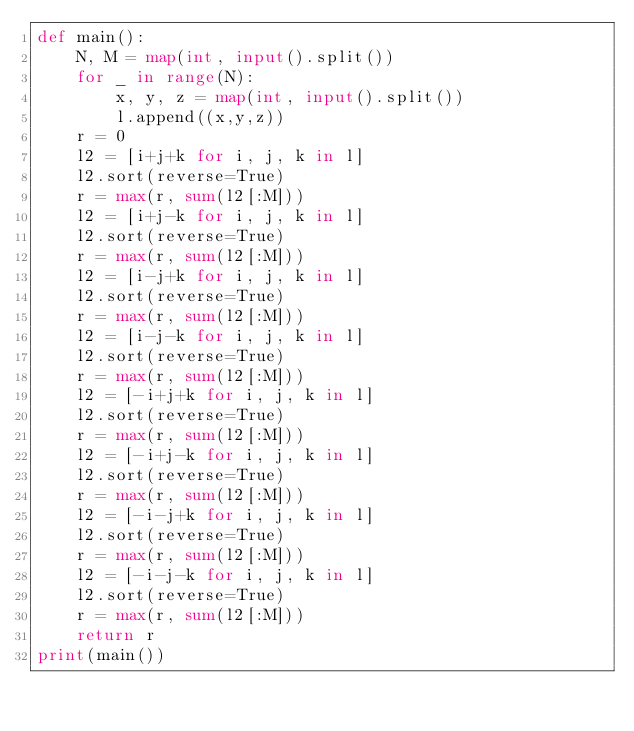<code> <loc_0><loc_0><loc_500><loc_500><_Python_>def main():
    N, M = map(int, input().split())
    for _ in range(N):
        x, y, z = map(int, input().split())
        l.append((x,y,z))
    r = 0
    l2 = [i+j+k for i, j, k in l]
    l2.sort(reverse=True)
    r = max(r, sum(l2[:M]))
    l2 = [i+j-k for i, j, k in l]
    l2.sort(reverse=True)
    r = max(r, sum(l2[:M]))
    l2 = [i-j+k for i, j, k in l]
    l2.sort(reverse=True)
    r = max(r, sum(l2[:M]))
    l2 = [i-j-k for i, j, k in l]
    l2.sort(reverse=True)
    r = max(r, sum(l2[:M]))
    l2 = [-i+j+k for i, j, k in l]
    l2.sort(reverse=True)
    r = max(r, sum(l2[:M]))
    l2 = [-i+j-k for i, j, k in l]
    l2.sort(reverse=True)
    r = max(r, sum(l2[:M]))
    l2 = [-i-j+k for i, j, k in l]
    l2.sort(reverse=True)
    r = max(r, sum(l2[:M]))
    l2 = [-i-j-k for i, j, k in l]
    l2.sort(reverse=True)
    r = max(r, sum(l2[:M]))
    return r
print(main())
</code> 